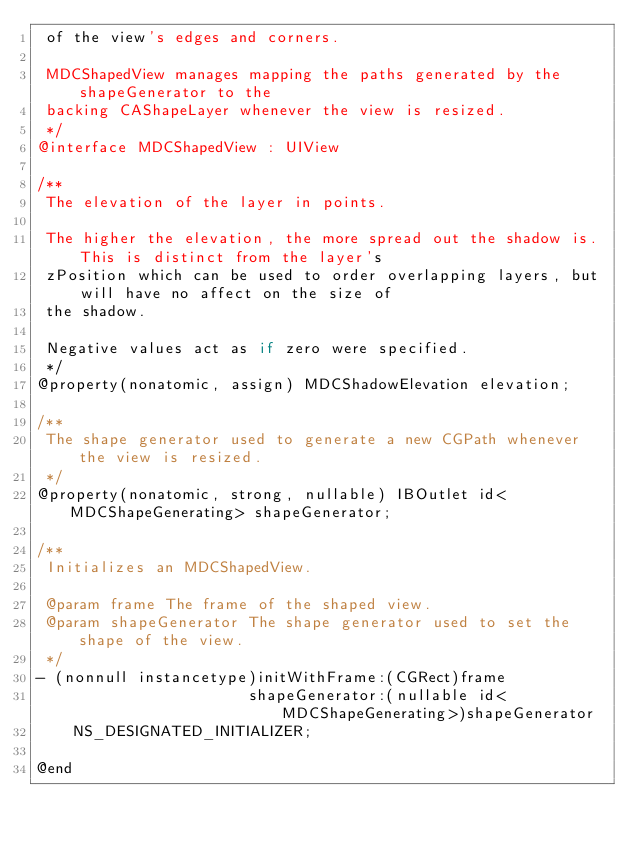<code> <loc_0><loc_0><loc_500><loc_500><_C_> of the view's edges and corners.

 MDCShapedView manages mapping the paths generated by the shapeGenerator to the
 backing CAShapeLayer whenever the view is resized.
 */
@interface MDCShapedView : UIView

/**
 The elevation of the layer in points.

 The higher the elevation, the more spread out the shadow is. This is distinct from the layer's
 zPosition which can be used to order overlapping layers, but will have no affect on the size of
 the shadow.

 Negative values act as if zero were specified.
 */
@property(nonatomic, assign) MDCShadowElevation elevation;

/**
 The shape generator used to generate a new CGPath whenever the view is resized.
 */
@property(nonatomic, strong, nullable) IBOutlet id<MDCShapeGenerating> shapeGenerator;

/**
 Initializes an MDCShapedView.

 @param frame The frame of the shaped view.
 @param shapeGenerator The shape generator used to set the shape of the view.
 */
- (nonnull instancetype)initWithFrame:(CGRect)frame
                       shapeGenerator:(nullable id<MDCShapeGenerating>)shapeGenerator
    NS_DESIGNATED_INITIALIZER;

@end
</code> 